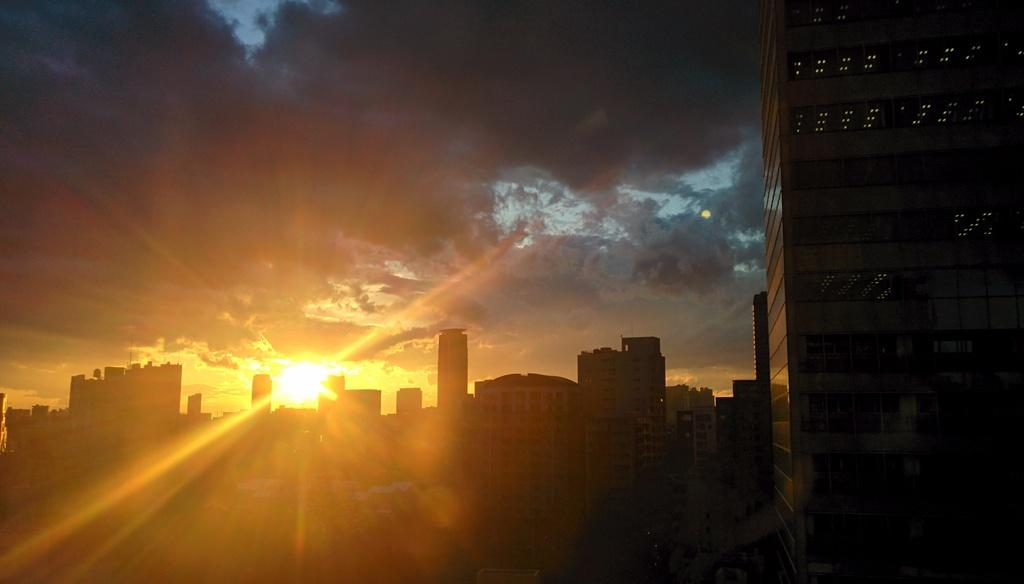What type of structures can be seen in the foreground of the picture? There are buildings in the foreground of the picture. What is the primary source of light in the picture? The sun is shining in the center of the picture. What can be seen in the sky in the picture? There are clouds visible at the top of the picture. What type of trouble are the dolls causing in the picture? There are no dolls present in the picture, so it is not possible to determine if they are causing any trouble. 